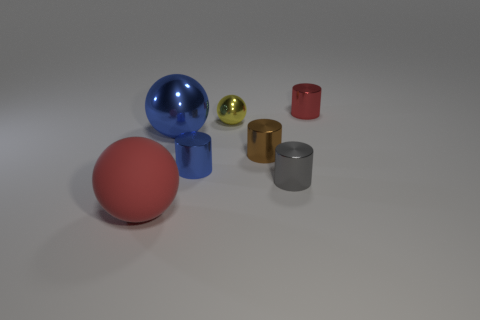Subtract all green cylinders. Subtract all cyan balls. How many cylinders are left? 4 Add 1 big matte things. How many objects exist? 8 Subtract all balls. How many objects are left? 4 Subtract all red metal things. Subtract all shiny things. How many objects are left? 0 Add 4 large things. How many large things are left? 6 Add 2 tiny brown metal things. How many tiny brown metal things exist? 3 Subtract 1 blue cylinders. How many objects are left? 6 